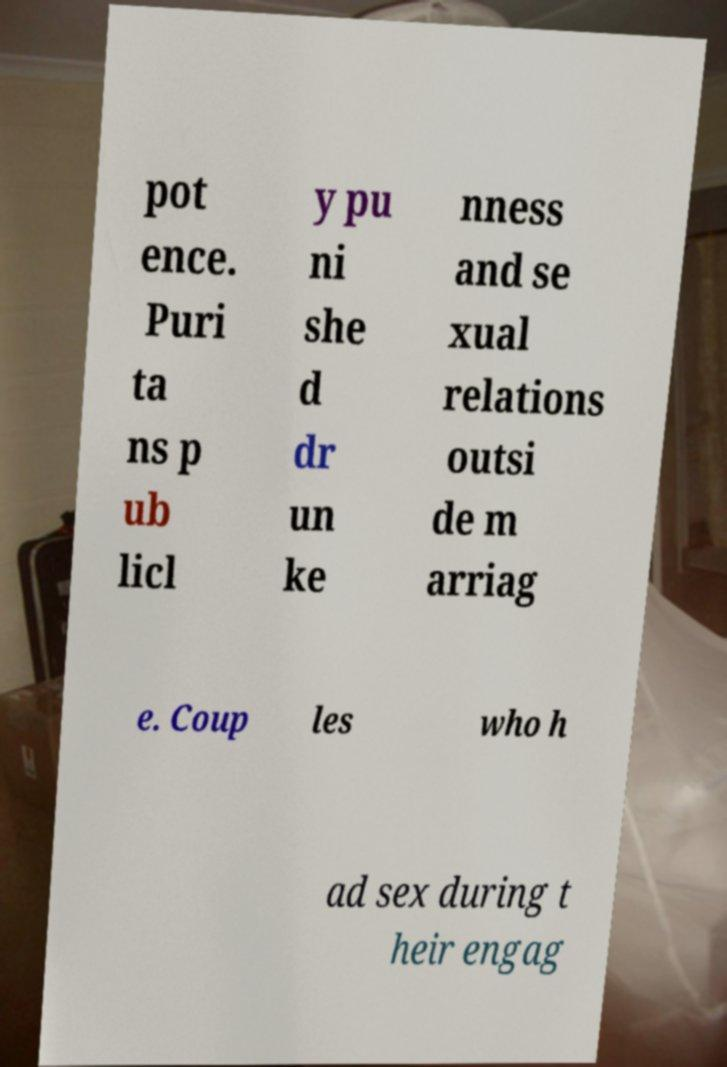Could you extract and type out the text from this image? pot ence. Puri ta ns p ub licl y pu ni she d dr un ke nness and se xual relations outsi de m arriag e. Coup les who h ad sex during t heir engag 